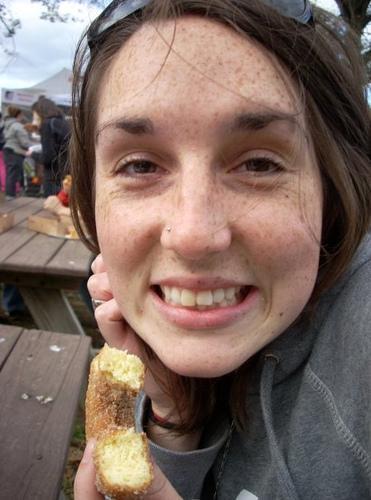How many people can be seen?
Give a very brief answer. 2. How many dining tables are in the picture?
Give a very brief answer. 2. How many chairs are navy blue?
Give a very brief answer. 0. 